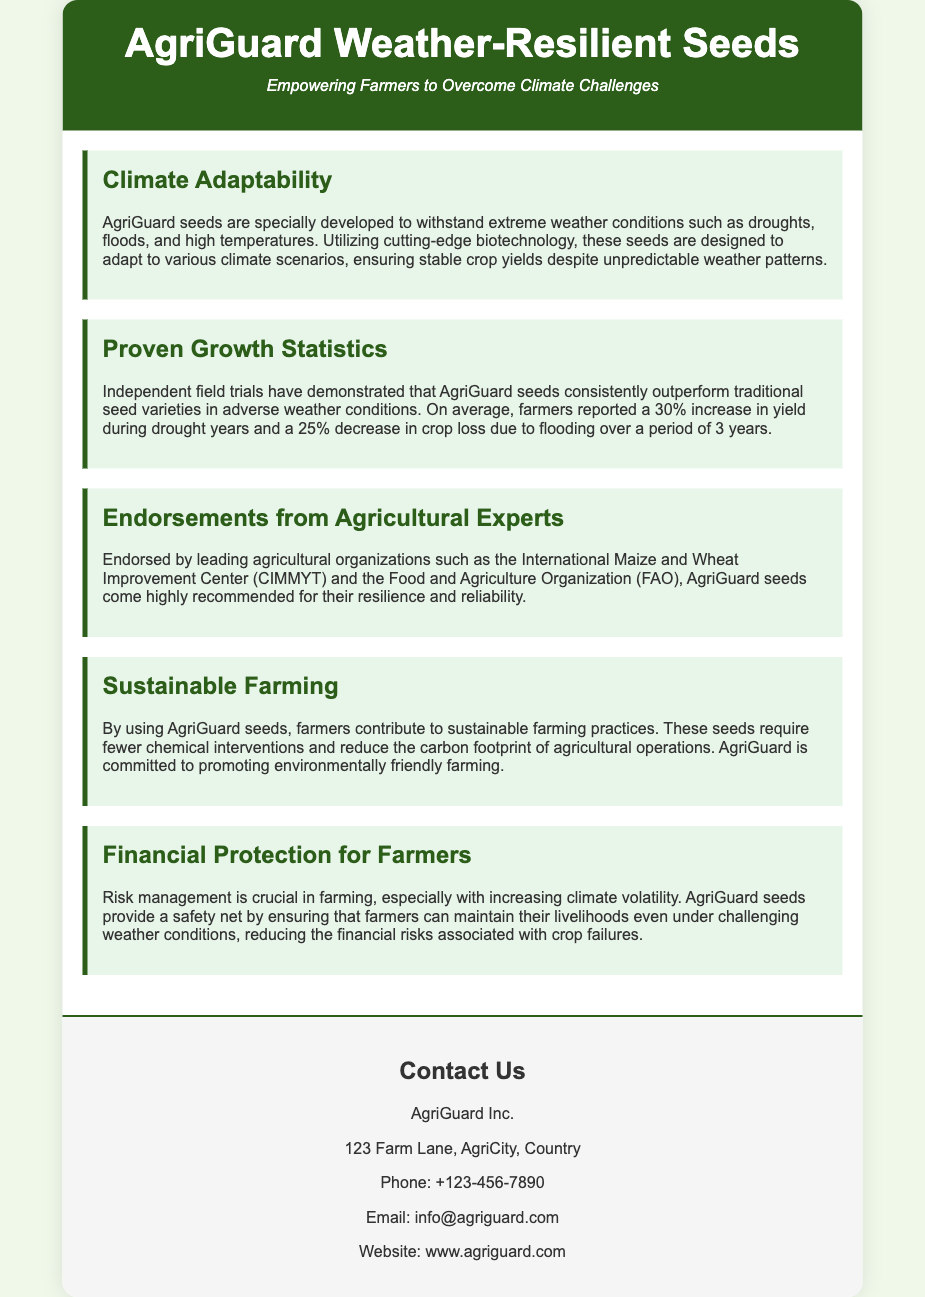what is the tagline of the product? The tagline of the product is mentioned in the header, emphasizing the goal of empowering farmers.
Answer: Empowering Farmers to Overcome Climate Challenges what percentage increase in yield do farmers report during drought years? This statistic is provided under the Proven Growth Statistics section of the document, indicating the performance of AgriGuard seeds during droughts.
Answer: 30% which organization endorses AgriGuard seeds? The endorsement is provided in the Endorsements from Agricultural Experts section, highlighting reputable organizations that support the product.
Answer: International Maize and Wheat Improvement Center (CIMMYT) what is the address of AgriGuard Inc.? The contact information includes the address of the company, which is listed at the bottom of the document.
Answer: 123 Farm Lane, AgriCity, Country how much crop loss reduction do AgriGuard seeds provide during flooding? This figure is found in the Proven Growth Statistics section and reflects the impact of AgriGuard seeds in flood conditions.
Answer: 25% what is one aspect of sustainable farming mentioned? The Sustainable Farming section highlights a key benefit of using AgriGuard seeds related to environmental impact.
Answer: Require fewer chemical interventions why is risk management mentioned in the context of AgriGuard seeds? The Financial Protection for Farmers section emphasizes the importance of AgriGuard seeds in mitigating financial risks due to climate volatility.
Answer: Mitigating financial risks 